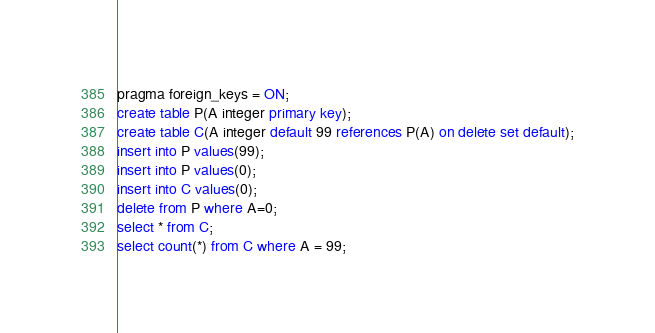Convert code to text. <code><loc_0><loc_0><loc_500><loc_500><_SQL_>pragma foreign_keys = ON;
create table P(A integer primary key);
create table C(A integer default 99 references P(A) on delete set default);
insert into P values(99);
insert into P values(0);
insert into C values(0);
delete from P where A=0;
select * from C;
select count(*) from C where A = 99;

</code> 